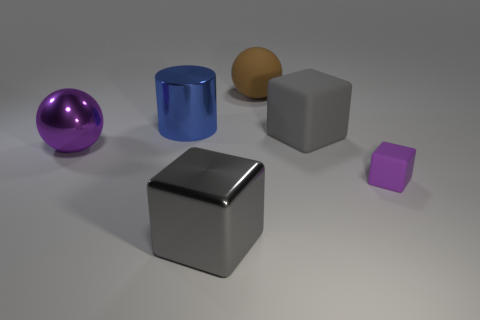Subtract all big matte cubes. How many cubes are left? 2 Add 1 red rubber blocks. How many objects exist? 7 Subtract 1 balls. How many balls are left? 1 Subtract all purple cubes. How many cubes are left? 2 Subtract all spheres. How many objects are left? 4 Subtract all red cubes. Subtract all red balls. How many cubes are left? 3 Subtract all green spheres. How many gray blocks are left? 2 Subtract all large brown matte things. Subtract all gray rubber cubes. How many objects are left? 4 Add 4 large gray shiny objects. How many large gray shiny objects are left? 5 Add 5 green metal cylinders. How many green metal cylinders exist? 5 